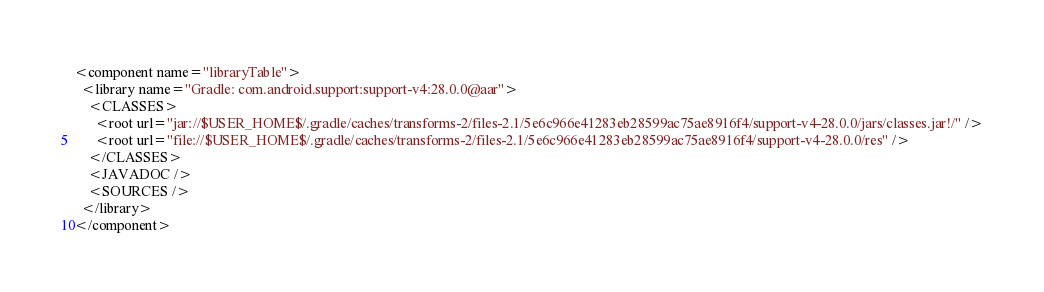<code> <loc_0><loc_0><loc_500><loc_500><_XML_><component name="libraryTable">
  <library name="Gradle: com.android.support:support-v4:28.0.0@aar">
    <CLASSES>
      <root url="jar://$USER_HOME$/.gradle/caches/transforms-2/files-2.1/5e6c966e41283eb28599ac75ae8916f4/support-v4-28.0.0/jars/classes.jar!/" />
      <root url="file://$USER_HOME$/.gradle/caches/transforms-2/files-2.1/5e6c966e41283eb28599ac75ae8916f4/support-v4-28.0.0/res" />
    </CLASSES>
    <JAVADOC />
    <SOURCES />
  </library>
</component></code> 